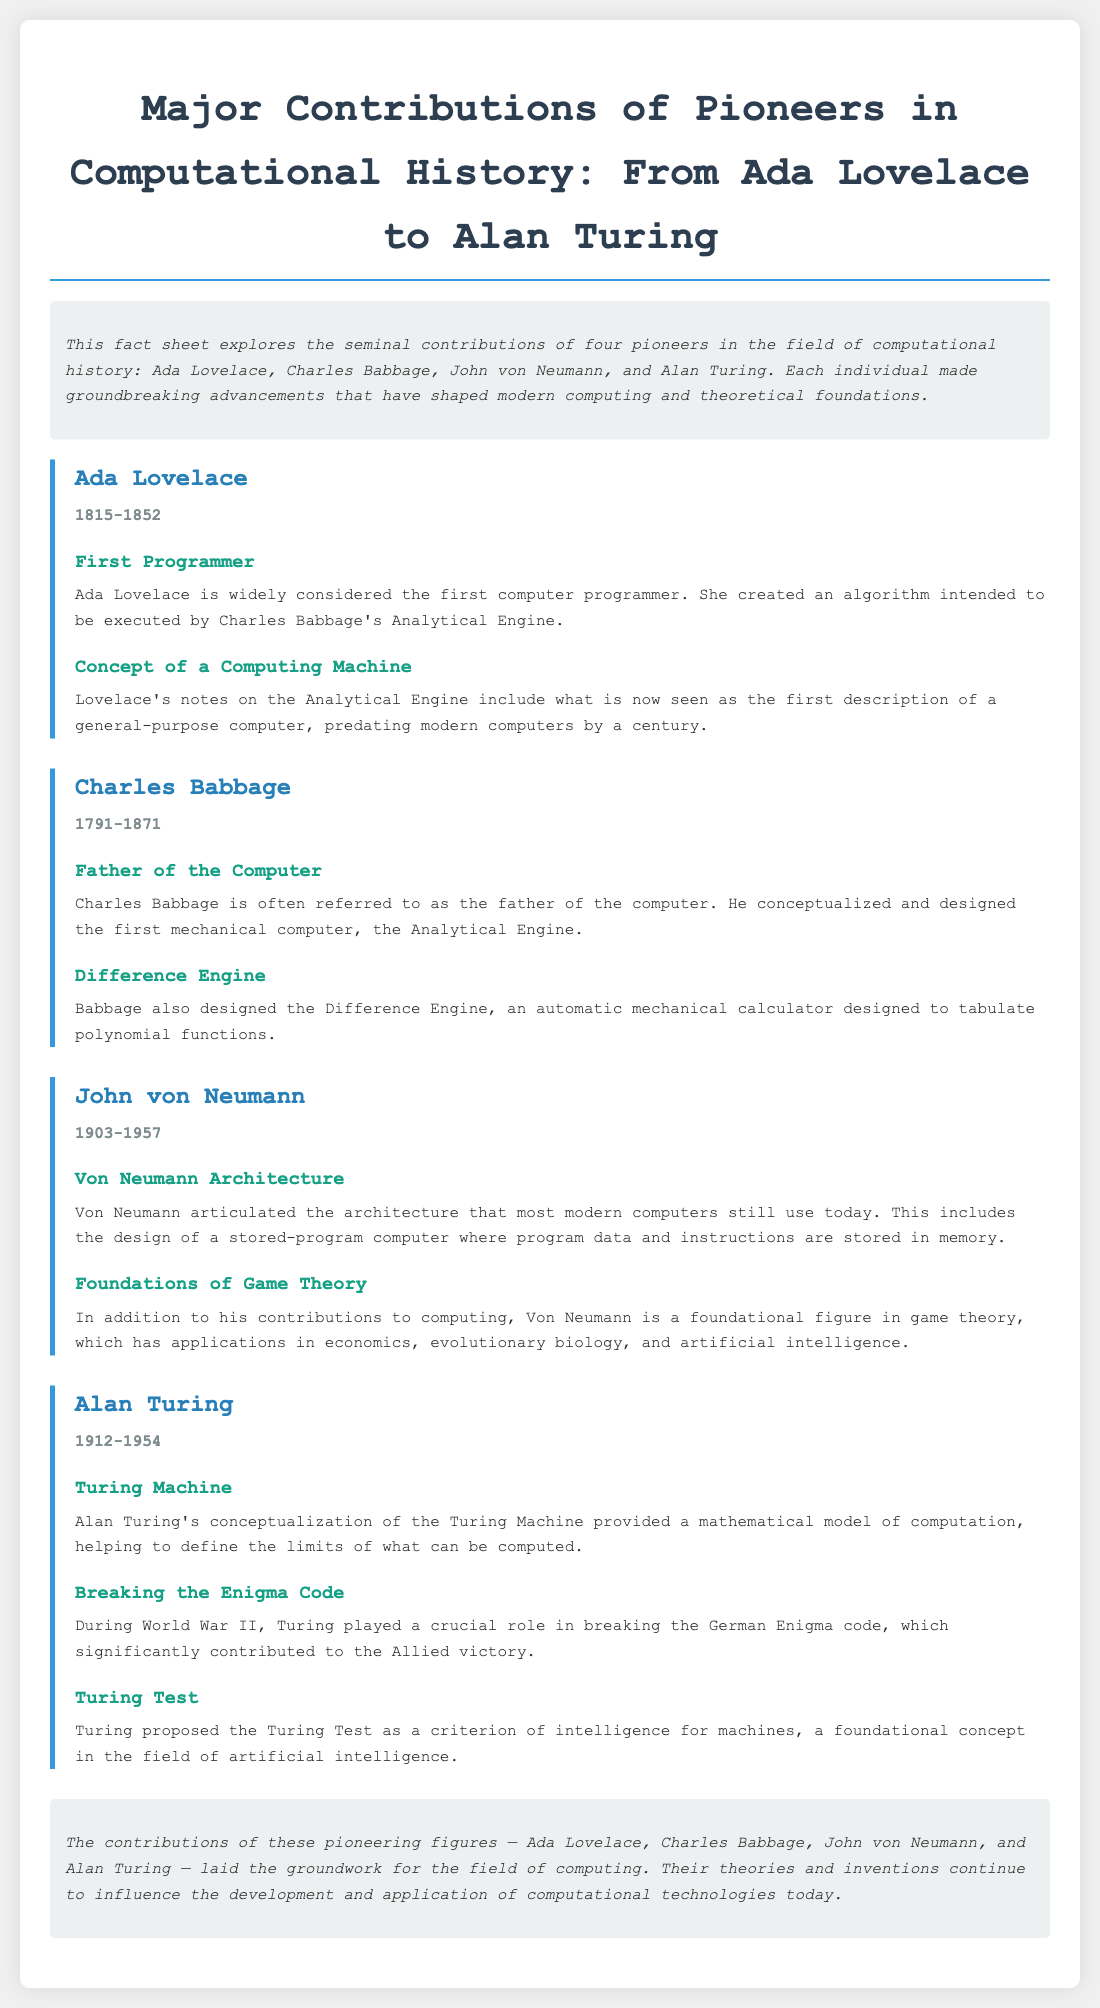what years did Ada Lovelace live? The document states that Ada Lovelace lived from 1815 to 1852.
Answer: 1815-1852 who is known as the father of the computer? According to the document, Charles Babbage is often referred to as the father of the computer.
Answer: Charles Babbage what did John von Neumann articulate? The document mentions that John von Neumann articulated the architecture used in most modern computers today.
Answer: Von Neumann Architecture which mathematical model did Alan Turing conceptualize? The document states that Alan Turing conceptualized the Turing Machine as a mathematical model of computation.
Answer: Turing Machine what significant contribution did Turing make during World War II? The document highlights that Turing played a crucial role in breaking the German Enigma code during World War II.
Answer: Breaking the Enigma Code what is the title of the fact sheet? The document provides the title: Major Contributions of Pioneers in Computational History: From Ada Lovelace to Alan Turing.
Answer: Major Contributions of Pioneers in Computational History: From Ada Lovelace to Alan Turing how many contributions are listed for Alan Turing? The document lists three contributions for Alan Turing.
Answer: Three what does the conclusion highlight? The conclusion summarizes how the contributions of the pioneers laid the groundwork for the field of computing.
Answer: Groundwork for the field of computing 